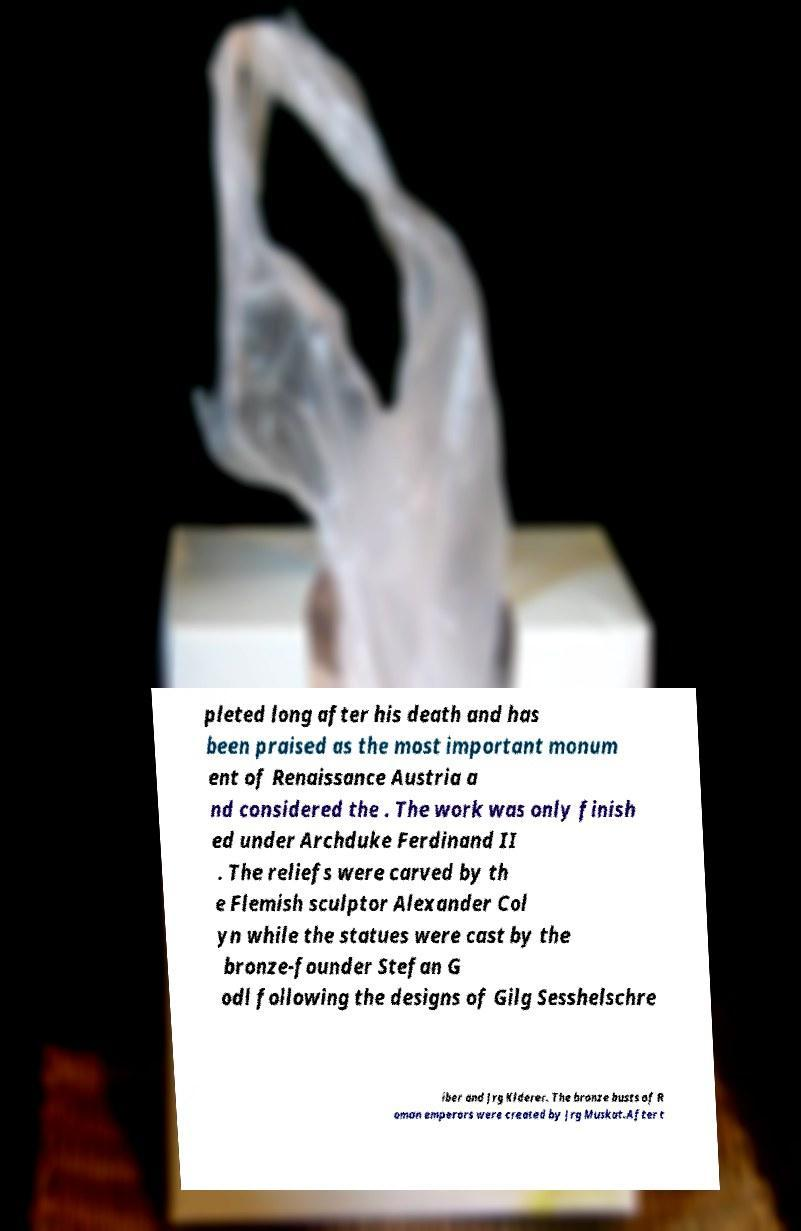There's text embedded in this image that I need extracted. Can you transcribe it verbatim? pleted long after his death and has been praised as the most important monum ent of Renaissance Austria a nd considered the . The work was only finish ed under Archduke Ferdinand II . The reliefs were carved by th e Flemish sculptor Alexander Col yn while the statues were cast by the bronze-founder Stefan G odl following the designs of Gilg Sesshelschre iber and Jrg Klderer. The bronze busts of R oman emperors were created by Jrg Muskat.After t 